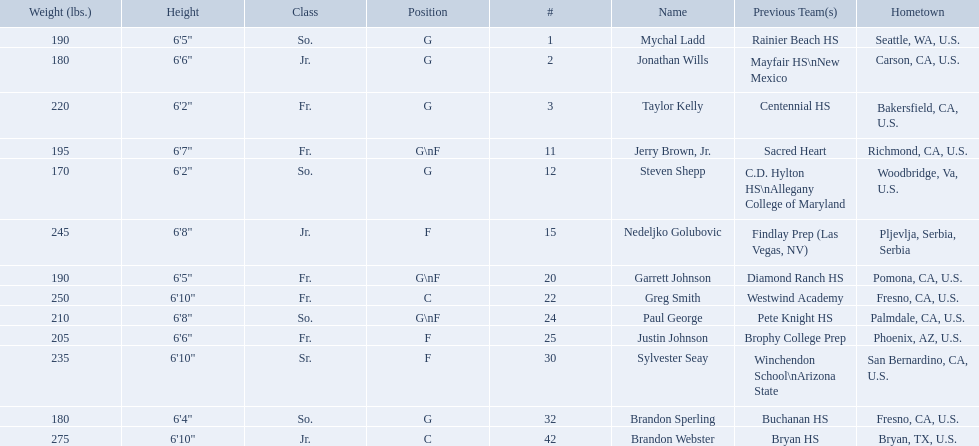What are the names of the basketball team players? Mychal Ladd, Jonathan Wills, Taylor Kelly, Jerry Brown, Jr., Steven Shepp, Nedeljko Golubovic, Garrett Johnson, Greg Smith, Paul George, Justin Johnson, Sylvester Seay, Brandon Sperling, Brandon Webster. Of these identify paul george and greg smith Greg Smith, Paul George. What are their corresponding heights? 6'10", 6'8". To who does the larger height correspond to? Greg Smith. Would you mind parsing the complete table? {'header': ['Weight (lbs.)', 'Height', 'Class', 'Position', '#', 'Name', 'Previous Team(s)', 'Hometown'], 'rows': [['190', '6\'5"', 'So.', 'G', '1', 'Mychal Ladd', 'Rainier Beach HS', 'Seattle, WA, U.S.'], ['180', '6\'6"', 'Jr.', 'G', '2', 'Jonathan Wills', 'Mayfair HS\\nNew Mexico', 'Carson, CA, U.S.'], ['220', '6\'2"', 'Fr.', 'G', '3', 'Taylor Kelly', 'Centennial HS', 'Bakersfield, CA, U.S.'], ['195', '6\'7"', 'Fr.', 'G\\nF', '11', 'Jerry Brown, Jr.', 'Sacred Heart', 'Richmond, CA, U.S.'], ['170', '6\'2"', 'So.', 'G', '12', 'Steven Shepp', 'C.D. Hylton HS\\nAllegany College of Maryland', 'Woodbridge, Va, U.S.'], ['245', '6\'8"', 'Jr.', 'F', '15', 'Nedeljko Golubovic', 'Findlay Prep (Las Vegas, NV)', 'Pljevlja, Serbia, Serbia'], ['190', '6\'5"', 'Fr.', 'G\\nF', '20', 'Garrett Johnson', 'Diamond Ranch HS', 'Pomona, CA, U.S.'], ['250', '6\'10"', 'Fr.', 'C', '22', 'Greg Smith', 'Westwind Academy', 'Fresno, CA, U.S.'], ['210', '6\'8"', 'So.', 'G\\nF', '24', 'Paul George', 'Pete Knight HS', 'Palmdale, CA, U.S.'], ['205', '6\'6"', 'Fr.', 'F', '25', 'Justin Johnson', 'Brophy College Prep', 'Phoenix, AZ, U.S.'], ['235', '6\'10"', 'Sr.', 'F', '30', 'Sylvester Seay', 'Winchendon School\\nArizona State', 'San Bernardino, CA, U.S.'], ['180', '6\'4"', 'So.', 'G', '32', 'Brandon Sperling', 'Buchanan HS', 'Fresno, CA, U.S.'], ['275', '6\'10"', 'Jr.', 'C', '42', 'Brandon Webster', 'Bryan HS', 'Bryan, TX, U.S.']]} Who are all the players? Mychal Ladd, Jonathan Wills, Taylor Kelly, Jerry Brown, Jr., Steven Shepp, Nedeljko Golubovic, Garrett Johnson, Greg Smith, Paul George, Justin Johnson, Sylvester Seay, Brandon Sperling, Brandon Webster. How tall are they? 6'5", 6'6", 6'2", 6'7", 6'2", 6'8", 6'5", 6'10", 6'8", 6'6", 6'10", 6'4", 6'10". What about just paul george and greg smitih? 6'10", 6'8". And which of the two is taller? Greg Smith. 